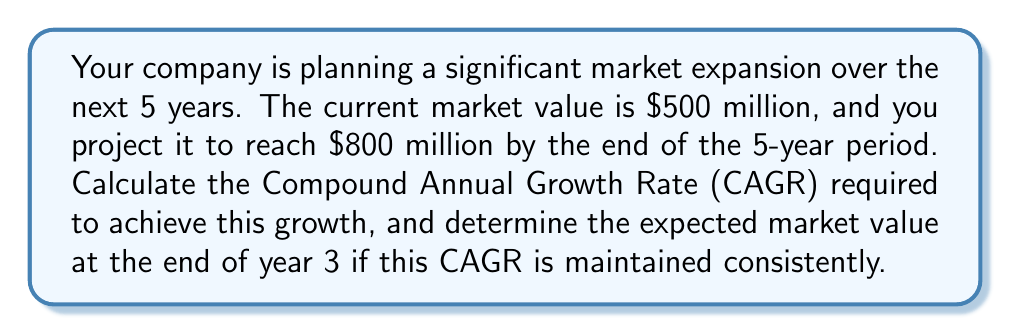Can you solve this math problem? To solve this problem, we'll follow these steps:

1. Calculate the CAGR:
   The formula for CAGR is:
   
   $$ CAGR = \left(\frac{Ending Value}{Beginning Value}\right)^{\frac{1}{n}} - 1 $$
   
   Where n is the number of years.

   Plugging in our values:
   
   $$ CAGR = \left(\frac{800}{500}\right)^{\frac{1}{5}} - 1 $$
   
   $$ CAGR = (1.6)^{0.2} - 1 $$
   
   $$ CAGR \approx 0.0988 \text{ or } 9.88\% $$

2. Calculate the market value at the end of year 3:
   We can use the CAGR to project the market value after 3 years using the formula:
   
   $$ Future Value = Present Value \times (1 + CAGR)^n $$
   
   Where n is now 3 years.

   $$ Future Value = 500 \times (1 + 0.0988)^3 $$
   
   $$ Future Value = 500 \times (1.0988)^3 $$
   
   $$ Future Value = 500 \times 1.3270 $$
   
   $$ Future Value \approx 663.5 \text{ million dollars} $$
Answer: The required CAGR is approximately 9.88%, and the expected market value at the end of year 3 is approximately $663.5 million. 